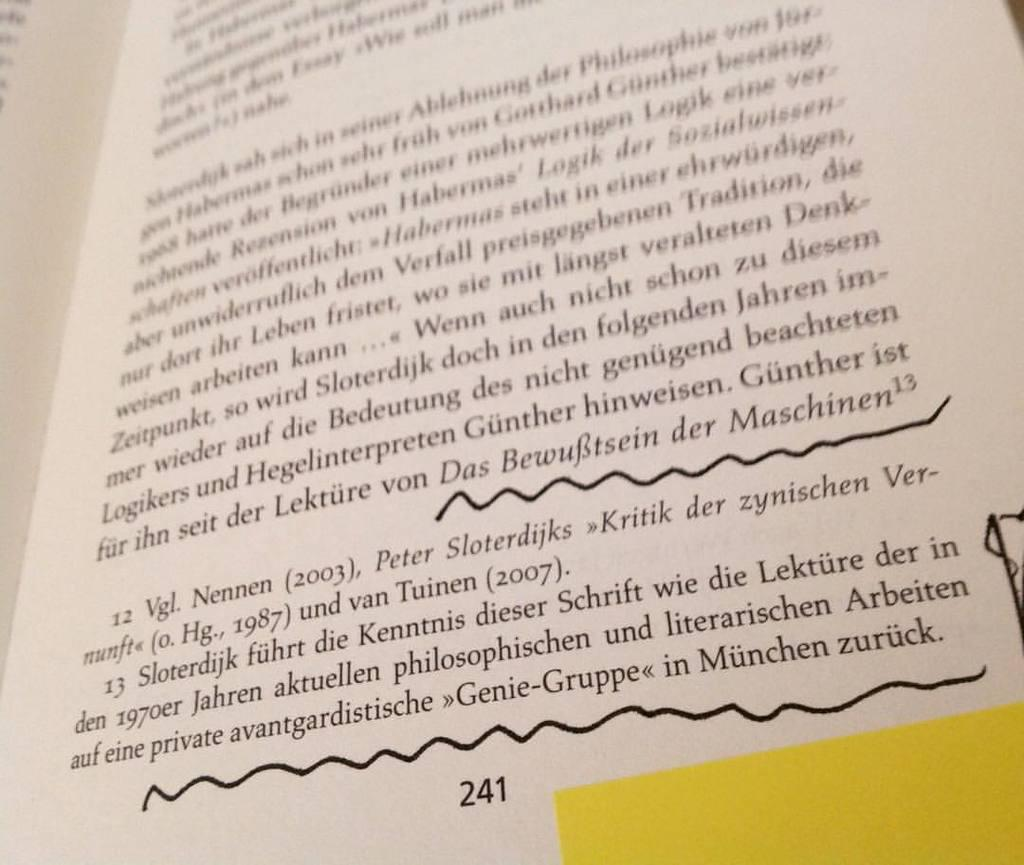<image>
Describe the image concisely. page number 241 of a book written in a foreign language. 